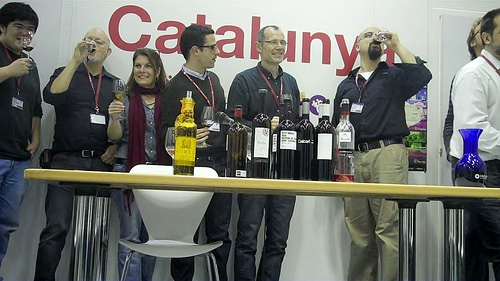Describe the objects in this image and their specific colors. I can see dining table in darkgray, black, tan, gray, and darkgreen tones, people in darkgray, black, gray, and tan tones, people in darkgray, black, and gray tones, people in darkgray, black, and gray tones, and people in darkgray, black, gray, navy, and darkblue tones in this image. 